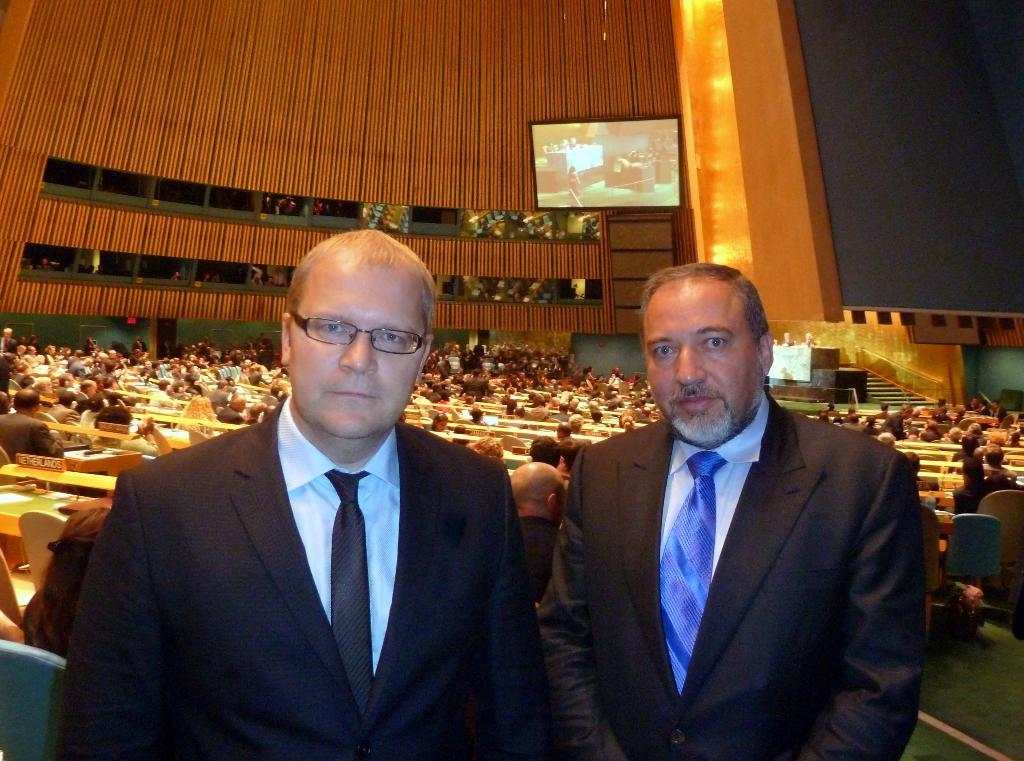How many people are in the image? There are a few people in the image. What can be seen beneath the people in the image? The ground is visible in the image. What type of furniture is present in the image? There are chairs in the image. What architectural feature is present in the image? There are stairs in the image. What type of structure is visible in the image? There is a wall in the image. What type of electronic device is present in the image? There is a television in the image. What type of support structure is present in the image? There are pillars in the image. What type of coal is being used to paint the pillars in the image? There is no coal or painting activity present in the image. How many feathers can be seen on the people in the image? There are no feathers visible on the people in the image. 